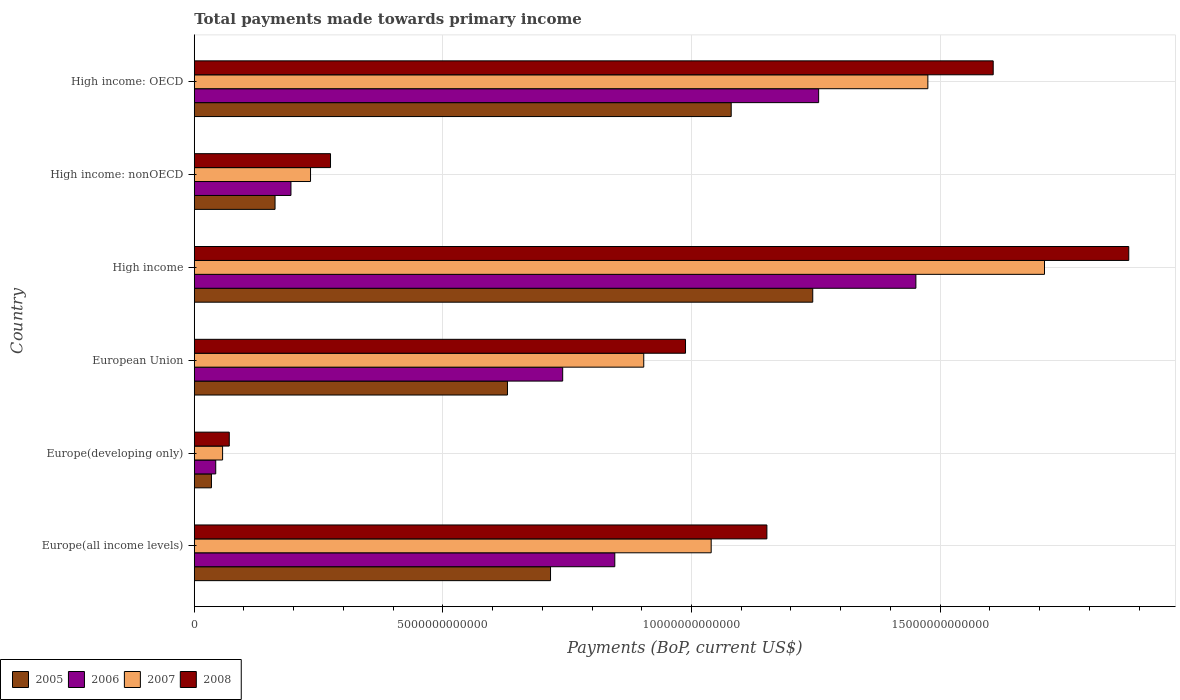How many groups of bars are there?
Make the answer very short. 6. How many bars are there on the 3rd tick from the bottom?
Your answer should be compact. 4. What is the label of the 1st group of bars from the top?
Your answer should be compact. High income: OECD. What is the total payments made towards primary income in 2008 in High income?
Your response must be concise. 1.88e+13. Across all countries, what is the maximum total payments made towards primary income in 2007?
Provide a succinct answer. 1.71e+13. Across all countries, what is the minimum total payments made towards primary income in 2005?
Offer a very short reply. 3.46e+11. In which country was the total payments made towards primary income in 2007 minimum?
Your response must be concise. Europe(developing only). What is the total total payments made towards primary income in 2007 in the graph?
Your answer should be compact. 5.42e+13. What is the difference between the total payments made towards primary income in 2006 in Europe(developing only) and that in High income?
Make the answer very short. -1.41e+13. What is the difference between the total payments made towards primary income in 2007 in Europe(developing only) and the total payments made towards primary income in 2006 in Europe(all income levels)?
Your answer should be compact. -7.89e+12. What is the average total payments made towards primary income in 2006 per country?
Your answer should be very brief. 7.55e+12. What is the difference between the total payments made towards primary income in 2007 and total payments made towards primary income in 2008 in European Union?
Offer a terse response. -8.40e+11. In how many countries, is the total payments made towards primary income in 2005 greater than 18000000000000 US$?
Keep it short and to the point. 0. What is the ratio of the total payments made towards primary income in 2006 in European Union to that in High income: OECD?
Your response must be concise. 0.59. What is the difference between the highest and the second highest total payments made towards primary income in 2005?
Give a very brief answer. 1.64e+12. What is the difference between the highest and the lowest total payments made towards primary income in 2007?
Offer a very short reply. 1.65e+13. Is the sum of the total payments made towards primary income in 2006 in High income and High income: OECD greater than the maximum total payments made towards primary income in 2008 across all countries?
Make the answer very short. Yes. Is it the case that in every country, the sum of the total payments made towards primary income in 2008 and total payments made towards primary income in 2006 is greater than the sum of total payments made towards primary income in 2007 and total payments made towards primary income in 2005?
Make the answer very short. No. What does the 3rd bar from the bottom in High income: nonOECD represents?
Provide a succinct answer. 2007. How many countries are there in the graph?
Provide a short and direct response. 6. What is the difference between two consecutive major ticks on the X-axis?
Give a very brief answer. 5.00e+12. Where does the legend appear in the graph?
Provide a succinct answer. Bottom left. How are the legend labels stacked?
Your answer should be very brief. Horizontal. What is the title of the graph?
Provide a short and direct response. Total payments made towards primary income. What is the label or title of the X-axis?
Provide a succinct answer. Payments (BoP, current US$). What is the Payments (BoP, current US$) in 2005 in Europe(all income levels)?
Your answer should be compact. 7.16e+12. What is the Payments (BoP, current US$) of 2006 in Europe(all income levels)?
Keep it short and to the point. 8.46e+12. What is the Payments (BoP, current US$) of 2007 in Europe(all income levels)?
Your answer should be compact. 1.04e+13. What is the Payments (BoP, current US$) of 2008 in Europe(all income levels)?
Your answer should be compact. 1.15e+13. What is the Payments (BoP, current US$) of 2005 in Europe(developing only)?
Provide a succinct answer. 3.46e+11. What is the Payments (BoP, current US$) of 2006 in Europe(developing only)?
Make the answer very short. 4.32e+11. What is the Payments (BoP, current US$) in 2007 in Europe(developing only)?
Provide a short and direct response. 5.70e+11. What is the Payments (BoP, current US$) of 2008 in Europe(developing only)?
Provide a short and direct response. 7.04e+11. What is the Payments (BoP, current US$) of 2005 in European Union?
Your answer should be compact. 6.30e+12. What is the Payments (BoP, current US$) in 2006 in European Union?
Your response must be concise. 7.41e+12. What is the Payments (BoP, current US$) in 2007 in European Union?
Provide a short and direct response. 9.04e+12. What is the Payments (BoP, current US$) of 2008 in European Union?
Your answer should be compact. 9.88e+12. What is the Payments (BoP, current US$) in 2005 in High income?
Your answer should be very brief. 1.24e+13. What is the Payments (BoP, current US$) of 2006 in High income?
Offer a very short reply. 1.45e+13. What is the Payments (BoP, current US$) in 2007 in High income?
Ensure brevity in your answer.  1.71e+13. What is the Payments (BoP, current US$) in 2008 in High income?
Provide a succinct answer. 1.88e+13. What is the Payments (BoP, current US$) in 2005 in High income: nonOECD?
Offer a very short reply. 1.62e+12. What is the Payments (BoP, current US$) of 2006 in High income: nonOECD?
Provide a succinct answer. 1.94e+12. What is the Payments (BoP, current US$) in 2007 in High income: nonOECD?
Provide a short and direct response. 2.34e+12. What is the Payments (BoP, current US$) of 2008 in High income: nonOECD?
Make the answer very short. 2.74e+12. What is the Payments (BoP, current US$) of 2005 in High income: OECD?
Your answer should be compact. 1.08e+13. What is the Payments (BoP, current US$) in 2006 in High income: OECD?
Offer a terse response. 1.26e+13. What is the Payments (BoP, current US$) in 2007 in High income: OECD?
Ensure brevity in your answer.  1.48e+13. What is the Payments (BoP, current US$) of 2008 in High income: OECD?
Provide a short and direct response. 1.61e+13. Across all countries, what is the maximum Payments (BoP, current US$) in 2005?
Offer a terse response. 1.24e+13. Across all countries, what is the maximum Payments (BoP, current US$) in 2006?
Make the answer very short. 1.45e+13. Across all countries, what is the maximum Payments (BoP, current US$) in 2007?
Your answer should be very brief. 1.71e+13. Across all countries, what is the maximum Payments (BoP, current US$) in 2008?
Your answer should be very brief. 1.88e+13. Across all countries, what is the minimum Payments (BoP, current US$) in 2005?
Your response must be concise. 3.46e+11. Across all countries, what is the minimum Payments (BoP, current US$) of 2006?
Offer a terse response. 4.32e+11. Across all countries, what is the minimum Payments (BoP, current US$) in 2007?
Your answer should be very brief. 5.70e+11. Across all countries, what is the minimum Payments (BoP, current US$) in 2008?
Offer a very short reply. 7.04e+11. What is the total Payments (BoP, current US$) in 2005 in the graph?
Offer a terse response. 3.87e+13. What is the total Payments (BoP, current US$) in 2006 in the graph?
Your answer should be compact. 4.53e+13. What is the total Payments (BoP, current US$) of 2007 in the graph?
Your answer should be compact. 5.42e+13. What is the total Payments (BoP, current US$) in 2008 in the graph?
Provide a succinct answer. 5.97e+13. What is the difference between the Payments (BoP, current US$) of 2005 in Europe(all income levels) and that in Europe(developing only)?
Your response must be concise. 6.82e+12. What is the difference between the Payments (BoP, current US$) of 2006 in Europe(all income levels) and that in Europe(developing only)?
Provide a succinct answer. 8.03e+12. What is the difference between the Payments (BoP, current US$) in 2007 in Europe(all income levels) and that in Europe(developing only)?
Your answer should be compact. 9.83e+12. What is the difference between the Payments (BoP, current US$) in 2008 in Europe(all income levels) and that in Europe(developing only)?
Offer a very short reply. 1.08e+13. What is the difference between the Payments (BoP, current US$) of 2005 in Europe(all income levels) and that in European Union?
Ensure brevity in your answer.  8.66e+11. What is the difference between the Payments (BoP, current US$) in 2006 in Europe(all income levels) and that in European Union?
Offer a very short reply. 1.05e+12. What is the difference between the Payments (BoP, current US$) of 2007 in Europe(all income levels) and that in European Union?
Offer a terse response. 1.36e+12. What is the difference between the Payments (BoP, current US$) in 2008 in Europe(all income levels) and that in European Union?
Provide a short and direct response. 1.64e+12. What is the difference between the Payments (BoP, current US$) in 2005 in Europe(all income levels) and that in High income?
Give a very brief answer. -5.27e+12. What is the difference between the Payments (BoP, current US$) in 2006 in Europe(all income levels) and that in High income?
Provide a succinct answer. -6.06e+12. What is the difference between the Payments (BoP, current US$) in 2007 in Europe(all income levels) and that in High income?
Your answer should be very brief. -6.70e+12. What is the difference between the Payments (BoP, current US$) in 2008 in Europe(all income levels) and that in High income?
Keep it short and to the point. -7.28e+12. What is the difference between the Payments (BoP, current US$) in 2005 in Europe(all income levels) and that in High income: nonOECD?
Your answer should be compact. 5.54e+12. What is the difference between the Payments (BoP, current US$) of 2006 in Europe(all income levels) and that in High income: nonOECD?
Offer a very short reply. 6.51e+12. What is the difference between the Payments (BoP, current US$) in 2007 in Europe(all income levels) and that in High income: nonOECD?
Provide a short and direct response. 8.06e+12. What is the difference between the Payments (BoP, current US$) of 2008 in Europe(all income levels) and that in High income: nonOECD?
Give a very brief answer. 8.78e+12. What is the difference between the Payments (BoP, current US$) of 2005 in Europe(all income levels) and that in High income: OECD?
Your answer should be compact. -3.63e+12. What is the difference between the Payments (BoP, current US$) of 2006 in Europe(all income levels) and that in High income: OECD?
Your response must be concise. -4.10e+12. What is the difference between the Payments (BoP, current US$) in 2007 in Europe(all income levels) and that in High income: OECD?
Ensure brevity in your answer.  -4.36e+12. What is the difference between the Payments (BoP, current US$) of 2008 in Europe(all income levels) and that in High income: OECD?
Ensure brevity in your answer.  -4.55e+12. What is the difference between the Payments (BoP, current US$) of 2005 in Europe(developing only) and that in European Union?
Your answer should be very brief. -5.95e+12. What is the difference between the Payments (BoP, current US$) in 2006 in Europe(developing only) and that in European Union?
Offer a terse response. -6.98e+12. What is the difference between the Payments (BoP, current US$) of 2007 in Europe(developing only) and that in European Union?
Give a very brief answer. -8.47e+12. What is the difference between the Payments (BoP, current US$) in 2008 in Europe(developing only) and that in European Union?
Keep it short and to the point. -9.18e+12. What is the difference between the Payments (BoP, current US$) in 2005 in Europe(developing only) and that in High income?
Your answer should be very brief. -1.21e+13. What is the difference between the Payments (BoP, current US$) in 2006 in Europe(developing only) and that in High income?
Your answer should be compact. -1.41e+13. What is the difference between the Payments (BoP, current US$) of 2007 in Europe(developing only) and that in High income?
Ensure brevity in your answer.  -1.65e+13. What is the difference between the Payments (BoP, current US$) in 2008 in Europe(developing only) and that in High income?
Make the answer very short. -1.81e+13. What is the difference between the Payments (BoP, current US$) of 2005 in Europe(developing only) and that in High income: nonOECD?
Offer a very short reply. -1.28e+12. What is the difference between the Payments (BoP, current US$) in 2006 in Europe(developing only) and that in High income: nonOECD?
Ensure brevity in your answer.  -1.51e+12. What is the difference between the Payments (BoP, current US$) of 2007 in Europe(developing only) and that in High income: nonOECD?
Give a very brief answer. -1.77e+12. What is the difference between the Payments (BoP, current US$) in 2008 in Europe(developing only) and that in High income: nonOECD?
Offer a terse response. -2.04e+12. What is the difference between the Payments (BoP, current US$) of 2005 in Europe(developing only) and that in High income: OECD?
Keep it short and to the point. -1.05e+13. What is the difference between the Payments (BoP, current US$) in 2006 in Europe(developing only) and that in High income: OECD?
Provide a short and direct response. -1.21e+13. What is the difference between the Payments (BoP, current US$) in 2007 in Europe(developing only) and that in High income: OECD?
Provide a succinct answer. -1.42e+13. What is the difference between the Payments (BoP, current US$) in 2008 in Europe(developing only) and that in High income: OECD?
Make the answer very short. -1.54e+13. What is the difference between the Payments (BoP, current US$) in 2005 in European Union and that in High income?
Ensure brevity in your answer.  -6.14e+12. What is the difference between the Payments (BoP, current US$) in 2006 in European Union and that in High income?
Offer a very short reply. -7.10e+12. What is the difference between the Payments (BoP, current US$) in 2007 in European Union and that in High income?
Your response must be concise. -8.06e+12. What is the difference between the Payments (BoP, current US$) in 2008 in European Union and that in High income?
Offer a terse response. -8.91e+12. What is the difference between the Payments (BoP, current US$) in 2005 in European Union and that in High income: nonOECD?
Make the answer very short. 4.67e+12. What is the difference between the Payments (BoP, current US$) of 2006 in European Union and that in High income: nonOECD?
Your answer should be compact. 5.47e+12. What is the difference between the Payments (BoP, current US$) in 2007 in European Union and that in High income: nonOECD?
Give a very brief answer. 6.70e+12. What is the difference between the Payments (BoP, current US$) of 2008 in European Union and that in High income: nonOECD?
Keep it short and to the point. 7.14e+12. What is the difference between the Payments (BoP, current US$) in 2005 in European Union and that in High income: OECD?
Make the answer very short. -4.50e+12. What is the difference between the Payments (BoP, current US$) of 2006 in European Union and that in High income: OECD?
Your answer should be very brief. -5.15e+12. What is the difference between the Payments (BoP, current US$) in 2007 in European Union and that in High income: OECD?
Give a very brief answer. -5.71e+12. What is the difference between the Payments (BoP, current US$) of 2008 in European Union and that in High income: OECD?
Offer a terse response. -6.19e+12. What is the difference between the Payments (BoP, current US$) of 2005 in High income and that in High income: nonOECD?
Provide a short and direct response. 1.08e+13. What is the difference between the Payments (BoP, current US$) in 2006 in High income and that in High income: nonOECD?
Provide a short and direct response. 1.26e+13. What is the difference between the Payments (BoP, current US$) of 2007 in High income and that in High income: nonOECD?
Give a very brief answer. 1.48e+13. What is the difference between the Payments (BoP, current US$) of 2008 in High income and that in High income: nonOECD?
Your answer should be very brief. 1.61e+13. What is the difference between the Payments (BoP, current US$) of 2005 in High income and that in High income: OECD?
Keep it short and to the point. 1.64e+12. What is the difference between the Payments (BoP, current US$) in 2006 in High income and that in High income: OECD?
Your answer should be very brief. 1.96e+12. What is the difference between the Payments (BoP, current US$) of 2007 in High income and that in High income: OECD?
Provide a succinct answer. 2.35e+12. What is the difference between the Payments (BoP, current US$) of 2008 in High income and that in High income: OECD?
Your response must be concise. 2.73e+12. What is the difference between the Payments (BoP, current US$) of 2005 in High income: nonOECD and that in High income: OECD?
Your answer should be compact. -9.17e+12. What is the difference between the Payments (BoP, current US$) in 2006 in High income: nonOECD and that in High income: OECD?
Your response must be concise. -1.06e+13. What is the difference between the Payments (BoP, current US$) in 2007 in High income: nonOECD and that in High income: OECD?
Offer a terse response. -1.24e+13. What is the difference between the Payments (BoP, current US$) of 2008 in High income: nonOECD and that in High income: OECD?
Ensure brevity in your answer.  -1.33e+13. What is the difference between the Payments (BoP, current US$) in 2005 in Europe(all income levels) and the Payments (BoP, current US$) in 2006 in Europe(developing only)?
Your answer should be compact. 6.73e+12. What is the difference between the Payments (BoP, current US$) of 2005 in Europe(all income levels) and the Payments (BoP, current US$) of 2007 in Europe(developing only)?
Provide a short and direct response. 6.60e+12. What is the difference between the Payments (BoP, current US$) of 2005 in Europe(all income levels) and the Payments (BoP, current US$) of 2008 in Europe(developing only)?
Your answer should be very brief. 6.46e+12. What is the difference between the Payments (BoP, current US$) in 2006 in Europe(all income levels) and the Payments (BoP, current US$) in 2007 in Europe(developing only)?
Provide a succinct answer. 7.89e+12. What is the difference between the Payments (BoP, current US$) in 2006 in Europe(all income levels) and the Payments (BoP, current US$) in 2008 in Europe(developing only)?
Provide a short and direct response. 7.75e+12. What is the difference between the Payments (BoP, current US$) of 2007 in Europe(all income levels) and the Payments (BoP, current US$) of 2008 in Europe(developing only)?
Your response must be concise. 9.69e+12. What is the difference between the Payments (BoP, current US$) of 2005 in Europe(all income levels) and the Payments (BoP, current US$) of 2006 in European Union?
Make the answer very short. -2.45e+11. What is the difference between the Payments (BoP, current US$) in 2005 in Europe(all income levels) and the Payments (BoP, current US$) in 2007 in European Union?
Provide a succinct answer. -1.87e+12. What is the difference between the Payments (BoP, current US$) in 2005 in Europe(all income levels) and the Payments (BoP, current US$) in 2008 in European Union?
Your answer should be compact. -2.71e+12. What is the difference between the Payments (BoP, current US$) in 2006 in Europe(all income levels) and the Payments (BoP, current US$) in 2007 in European Union?
Your answer should be compact. -5.82e+11. What is the difference between the Payments (BoP, current US$) of 2006 in Europe(all income levels) and the Payments (BoP, current US$) of 2008 in European Union?
Offer a terse response. -1.42e+12. What is the difference between the Payments (BoP, current US$) in 2007 in Europe(all income levels) and the Payments (BoP, current US$) in 2008 in European Union?
Your response must be concise. 5.16e+11. What is the difference between the Payments (BoP, current US$) of 2005 in Europe(all income levels) and the Payments (BoP, current US$) of 2006 in High income?
Give a very brief answer. -7.35e+12. What is the difference between the Payments (BoP, current US$) of 2005 in Europe(all income levels) and the Payments (BoP, current US$) of 2007 in High income?
Offer a terse response. -9.93e+12. What is the difference between the Payments (BoP, current US$) of 2005 in Europe(all income levels) and the Payments (BoP, current US$) of 2008 in High income?
Provide a short and direct response. -1.16e+13. What is the difference between the Payments (BoP, current US$) in 2006 in Europe(all income levels) and the Payments (BoP, current US$) in 2007 in High income?
Your answer should be very brief. -8.64e+12. What is the difference between the Payments (BoP, current US$) of 2006 in Europe(all income levels) and the Payments (BoP, current US$) of 2008 in High income?
Provide a short and direct response. -1.03e+13. What is the difference between the Payments (BoP, current US$) of 2007 in Europe(all income levels) and the Payments (BoP, current US$) of 2008 in High income?
Offer a terse response. -8.40e+12. What is the difference between the Payments (BoP, current US$) in 2005 in Europe(all income levels) and the Payments (BoP, current US$) in 2006 in High income: nonOECD?
Your response must be concise. 5.22e+12. What is the difference between the Payments (BoP, current US$) in 2005 in Europe(all income levels) and the Payments (BoP, current US$) in 2007 in High income: nonOECD?
Keep it short and to the point. 4.83e+12. What is the difference between the Payments (BoP, current US$) in 2005 in Europe(all income levels) and the Payments (BoP, current US$) in 2008 in High income: nonOECD?
Offer a very short reply. 4.42e+12. What is the difference between the Payments (BoP, current US$) in 2006 in Europe(all income levels) and the Payments (BoP, current US$) in 2007 in High income: nonOECD?
Your answer should be compact. 6.12e+12. What is the difference between the Payments (BoP, current US$) of 2006 in Europe(all income levels) and the Payments (BoP, current US$) of 2008 in High income: nonOECD?
Ensure brevity in your answer.  5.72e+12. What is the difference between the Payments (BoP, current US$) of 2007 in Europe(all income levels) and the Payments (BoP, current US$) of 2008 in High income: nonOECD?
Offer a very short reply. 7.66e+12. What is the difference between the Payments (BoP, current US$) in 2005 in Europe(all income levels) and the Payments (BoP, current US$) in 2006 in High income: OECD?
Give a very brief answer. -5.39e+12. What is the difference between the Payments (BoP, current US$) of 2005 in Europe(all income levels) and the Payments (BoP, current US$) of 2007 in High income: OECD?
Make the answer very short. -7.59e+12. What is the difference between the Payments (BoP, current US$) in 2005 in Europe(all income levels) and the Payments (BoP, current US$) in 2008 in High income: OECD?
Provide a short and direct response. -8.90e+12. What is the difference between the Payments (BoP, current US$) of 2006 in Europe(all income levels) and the Payments (BoP, current US$) of 2007 in High income: OECD?
Provide a short and direct response. -6.30e+12. What is the difference between the Payments (BoP, current US$) of 2006 in Europe(all income levels) and the Payments (BoP, current US$) of 2008 in High income: OECD?
Ensure brevity in your answer.  -7.61e+12. What is the difference between the Payments (BoP, current US$) of 2007 in Europe(all income levels) and the Payments (BoP, current US$) of 2008 in High income: OECD?
Your answer should be very brief. -5.67e+12. What is the difference between the Payments (BoP, current US$) in 2005 in Europe(developing only) and the Payments (BoP, current US$) in 2006 in European Union?
Offer a terse response. -7.06e+12. What is the difference between the Payments (BoP, current US$) of 2005 in Europe(developing only) and the Payments (BoP, current US$) of 2007 in European Union?
Give a very brief answer. -8.69e+12. What is the difference between the Payments (BoP, current US$) of 2005 in Europe(developing only) and the Payments (BoP, current US$) of 2008 in European Union?
Offer a very short reply. -9.53e+12. What is the difference between the Payments (BoP, current US$) in 2006 in Europe(developing only) and the Payments (BoP, current US$) in 2007 in European Union?
Ensure brevity in your answer.  -8.61e+12. What is the difference between the Payments (BoP, current US$) of 2006 in Europe(developing only) and the Payments (BoP, current US$) of 2008 in European Union?
Make the answer very short. -9.45e+12. What is the difference between the Payments (BoP, current US$) in 2007 in Europe(developing only) and the Payments (BoP, current US$) in 2008 in European Union?
Give a very brief answer. -9.31e+12. What is the difference between the Payments (BoP, current US$) in 2005 in Europe(developing only) and the Payments (BoP, current US$) in 2006 in High income?
Provide a succinct answer. -1.42e+13. What is the difference between the Payments (BoP, current US$) in 2005 in Europe(developing only) and the Payments (BoP, current US$) in 2007 in High income?
Provide a short and direct response. -1.68e+13. What is the difference between the Payments (BoP, current US$) of 2005 in Europe(developing only) and the Payments (BoP, current US$) of 2008 in High income?
Your answer should be compact. -1.84e+13. What is the difference between the Payments (BoP, current US$) of 2006 in Europe(developing only) and the Payments (BoP, current US$) of 2007 in High income?
Give a very brief answer. -1.67e+13. What is the difference between the Payments (BoP, current US$) of 2006 in Europe(developing only) and the Payments (BoP, current US$) of 2008 in High income?
Provide a succinct answer. -1.84e+13. What is the difference between the Payments (BoP, current US$) in 2007 in Europe(developing only) and the Payments (BoP, current US$) in 2008 in High income?
Offer a terse response. -1.82e+13. What is the difference between the Payments (BoP, current US$) of 2005 in Europe(developing only) and the Payments (BoP, current US$) of 2006 in High income: nonOECD?
Offer a terse response. -1.60e+12. What is the difference between the Payments (BoP, current US$) of 2005 in Europe(developing only) and the Payments (BoP, current US$) of 2007 in High income: nonOECD?
Give a very brief answer. -1.99e+12. What is the difference between the Payments (BoP, current US$) of 2005 in Europe(developing only) and the Payments (BoP, current US$) of 2008 in High income: nonOECD?
Offer a terse response. -2.39e+12. What is the difference between the Payments (BoP, current US$) in 2006 in Europe(developing only) and the Payments (BoP, current US$) in 2007 in High income: nonOECD?
Offer a very short reply. -1.91e+12. What is the difference between the Payments (BoP, current US$) in 2006 in Europe(developing only) and the Payments (BoP, current US$) in 2008 in High income: nonOECD?
Ensure brevity in your answer.  -2.31e+12. What is the difference between the Payments (BoP, current US$) of 2007 in Europe(developing only) and the Payments (BoP, current US$) of 2008 in High income: nonOECD?
Keep it short and to the point. -2.17e+12. What is the difference between the Payments (BoP, current US$) of 2005 in Europe(developing only) and the Payments (BoP, current US$) of 2006 in High income: OECD?
Provide a short and direct response. -1.22e+13. What is the difference between the Payments (BoP, current US$) of 2005 in Europe(developing only) and the Payments (BoP, current US$) of 2007 in High income: OECD?
Your answer should be compact. -1.44e+13. What is the difference between the Payments (BoP, current US$) in 2005 in Europe(developing only) and the Payments (BoP, current US$) in 2008 in High income: OECD?
Provide a succinct answer. -1.57e+13. What is the difference between the Payments (BoP, current US$) in 2006 in Europe(developing only) and the Payments (BoP, current US$) in 2007 in High income: OECD?
Ensure brevity in your answer.  -1.43e+13. What is the difference between the Payments (BoP, current US$) of 2006 in Europe(developing only) and the Payments (BoP, current US$) of 2008 in High income: OECD?
Give a very brief answer. -1.56e+13. What is the difference between the Payments (BoP, current US$) in 2007 in Europe(developing only) and the Payments (BoP, current US$) in 2008 in High income: OECD?
Offer a terse response. -1.55e+13. What is the difference between the Payments (BoP, current US$) in 2005 in European Union and the Payments (BoP, current US$) in 2006 in High income?
Give a very brief answer. -8.21e+12. What is the difference between the Payments (BoP, current US$) in 2005 in European Union and the Payments (BoP, current US$) in 2007 in High income?
Your answer should be compact. -1.08e+13. What is the difference between the Payments (BoP, current US$) in 2005 in European Union and the Payments (BoP, current US$) in 2008 in High income?
Offer a very short reply. -1.25e+13. What is the difference between the Payments (BoP, current US$) in 2006 in European Union and the Payments (BoP, current US$) in 2007 in High income?
Keep it short and to the point. -9.69e+12. What is the difference between the Payments (BoP, current US$) in 2006 in European Union and the Payments (BoP, current US$) in 2008 in High income?
Your response must be concise. -1.14e+13. What is the difference between the Payments (BoP, current US$) of 2007 in European Union and the Payments (BoP, current US$) of 2008 in High income?
Provide a succinct answer. -9.75e+12. What is the difference between the Payments (BoP, current US$) in 2005 in European Union and the Payments (BoP, current US$) in 2006 in High income: nonOECD?
Give a very brief answer. 4.35e+12. What is the difference between the Payments (BoP, current US$) of 2005 in European Union and the Payments (BoP, current US$) of 2007 in High income: nonOECD?
Offer a terse response. 3.96e+12. What is the difference between the Payments (BoP, current US$) in 2005 in European Union and the Payments (BoP, current US$) in 2008 in High income: nonOECD?
Keep it short and to the point. 3.56e+12. What is the difference between the Payments (BoP, current US$) of 2006 in European Union and the Payments (BoP, current US$) of 2007 in High income: nonOECD?
Your response must be concise. 5.07e+12. What is the difference between the Payments (BoP, current US$) in 2006 in European Union and the Payments (BoP, current US$) in 2008 in High income: nonOECD?
Offer a terse response. 4.67e+12. What is the difference between the Payments (BoP, current US$) of 2007 in European Union and the Payments (BoP, current US$) of 2008 in High income: nonOECD?
Your answer should be very brief. 6.30e+12. What is the difference between the Payments (BoP, current US$) in 2005 in European Union and the Payments (BoP, current US$) in 2006 in High income: OECD?
Keep it short and to the point. -6.26e+12. What is the difference between the Payments (BoP, current US$) in 2005 in European Union and the Payments (BoP, current US$) in 2007 in High income: OECD?
Ensure brevity in your answer.  -8.45e+12. What is the difference between the Payments (BoP, current US$) of 2005 in European Union and the Payments (BoP, current US$) of 2008 in High income: OECD?
Your answer should be very brief. -9.77e+12. What is the difference between the Payments (BoP, current US$) in 2006 in European Union and the Payments (BoP, current US$) in 2007 in High income: OECD?
Your response must be concise. -7.34e+12. What is the difference between the Payments (BoP, current US$) of 2006 in European Union and the Payments (BoP, current US$) of 2008 in High income: OECD?
Provide a short and direct response. -8.66e+12. What is the difference between the Payments (BoP, current US$) of 2007 in European Union and the Payments (BoP, current US$) of 2008 in High income: OECD?
Provide a short and direct response. -7.03e+12. What is the difference between the Payments (BoP, current US$) in 2005 in High income and the Payments (BoP, current US$) in 2006 in High income: nonOECD?
Keep it short and to the point. 1.05e+13. What is the difference between the Payments (BoP, current US$) of 2005 in High income and the Payments (BoP, current US$) of 2007 in High income: nonOECD?
Make the answer very short. 1.01e+13. What is the difference between the Payments (BoP, current US$) of 2005 in High income and the Payments (BoP, current US$) of 2008 in High income: nonOECD?
Make the answer very short. 9.70e+12. What is the difference between the Payments (BoP, current US$) in 2006 in High income and the Payments (BoP, current US$) in 2007 in High income: nonOECD?
Your response must be concise. 1.22e+13. What is the difference between the Payments (BoP, current US$) of 2006 in High income and the Payments (BoP, current US$) of 2008 in High income: nonOECD?
Give a very brief answer. 1.18e+13. What is the difference between the Payments (BoP, current US$) of 2007 in High income and the Payments (BoP, current US$) of 2008 in High income: nonOECD?
Give a very brief answer. 1.44e+13. What is the difference between the Payments (BoP, current US$) of 2005 in High income and the Payments (BoP, current US$) of 2006 in High income: OECD?
Your answer should be very brief. -1.18e+11. What is the difference between the Payments (BoP, current US$) of 2005 in High income and the Payments (BoP, current US$) of 2007 in High income: OECD?
Ensure brevity in your answer.  -2.32e+12. What is the difference between the Payments (BoP, current US$) of 2005 in High income and the Payments (BoP, current US$) of 2008 in High income: OECD?
Provide a short and direct response. -3.63e+12. What is the difference between the Payments (BoP, current US$) of 2006 in High income and the Payments (BoP, current US$) of 2007 in High income: OECD?
Your answer should be very brief. -2.41e+11. What is the difference between the Payments (BoP, current US$) of 2006 in High income and the Payments (BoP, current US$) of 2008 in High income: OECD?
Your answer should be compact. -1.55e+12. What is the difference between the Payments (BoP, current US$) in 2007 in High income and the Payments (BoP, current US$) in 2008 in High income: OECD?
Provide a succinct answer. 1.03e+12. What is the difference between the Payments (BoP, current US$) of 2005 in High income: nonOECD and the Payments (BoP, current US$) of 2006 in High income: OECD?
Your answer should be very brief. -1.09e+13. What is the difference between the Payments (BoP, current US$) in 2005 in High income: nonOECD and the Payments (BoP, current US$) in 2007 in High income: OECD?
Give a very brief answer. -1.31e+13. What is the difference between the Payments (BoP, current US$) of 2005 in High income: nonOECD and the Payments (BoP, current US$) of 2008 in High income: OECD?
Give a very brief answer. -1.44e+13. What is the difference between the Payments (BoP, current US$) in 2006 in High income: nonOECD and the Payments (BoP, current US$) in 2007 in High income: OECD?
Provide a short and direct response. -1.28e+13. What is the difference between the Payments (BoP, current US$) of 2006 in High income: nonOECD and the Payments (BoP, current US$) of 2008 in High income: OECD?
Offer a terse response. -1.41e+13. What is the difference between the Payments (BoP, current US$) of 2007 in High income: nonOECD and the Payments (BoP, current US$) of 2008 in High income: OECD?
Provide a succinct answer. -1.37e+13. What is the average Payments (BoP, current US$) in 2005 per country?
Give a very brief answer. 6.45e+12. What is the average Payments (BoP, current US$) in 2006 per country?
Your answer should be very brief. 7.55e+12. What is the average Payments (BoP, current US$) of 2007 per country?
Make the answer very short. 9.03e+12. What is the average Payments (BoP, current US$) in 2008 per country?
Keep it short and to the point. 9.95e+12. What is the difference between the Payments (BoP, current US$) of 2005 and Payments (BoP, current US$) of 2006 in Europe(all income levels)?
Give a very brief answer. -1.29e+12. What is the difference between the Payments (BoP, current US$) of 2005 and Payments (BoP, current US$) of 2007 in Europe(all income levels)?
Ensure brevity in your answer.  -3.23e+12. What is the difference between the Payments (BoP, current US$) in 2005 and Payments (BoP, current US$) in 2008 in Europe(all income levels)?
Provide a short and direct response. -4.35e+12. What is the difference between the Payments (BoP, current US$) in 2006 and Payments (BoP, current US$) in 2007 in Europe(all income levels)?
Keep it short and to the point. -1.94e+12. What is the difference between the Payments (BoP, current US$) of 2006 and Payments (BoP, current US$) of 2008 in Europe(all income levels)?
Your answer should be compact. -3.06e+12. What is the difference between the Payments (BoP, current US$) in 2007 and Payments (BoP, current US$) in 2008 in Europe(all income levels)?
Make the answer very short. -1.12e+12. What is the difference between the Payments (BoP, current US$) of 2005 and Payments (BoP, current US$) of 2006 in Europe(developing only)?
Make the answer very short. -8.59e+1. What is the difference between the Payments (BoP, current US$) in 2005 and Payments (BoP, current US$) in 2007 in Europe(developing only)?
Provide a short and direct response. -2.24e+11. What is the difference between the Payments (BoP, current US$) of 2005 and Payments (BoP, current US$) of 2008 in Europe(developing only)?
Offer a terse response. -3.58e+11. What is the difference between the Payments (BoP, current US$) of 2006 and Payments (BoP, current US$) of 2007 in Europe(developing only)?
Provide a short and direct response. -1.38e+11. What is the difference between the Payments (BoP, current US$) of 2006 and Payments (BoP, current US$) of 2008 in Europe(developing only)?
Provide a short and direct response. -2.72e+11. What is the difference between the Payments (BoP, current US$) in 2007 and Payments (BoP, current US$) in 2008 in Europe(developing only)?
Your answer should be compact. -1.34e+11. What is the difference between the Payments (BoP, current US$) in 2005 and Payments (BoP, current US$) in 2006 in European Union?
Keep it short and to the point. -1.11e+12. What is the difference between the Payments (BoP, current US$) in 2005 and Payments (BoP, current US$) in 2007 in European Union?
Give a very brief answer. -2.74e+12. What is the difference between the Payments (BoP, current US$) in 2005 and Payments (BoP, current US$) in 2008 in European Union?
Give a very brief answer. -3.58e+12. What is the difference between the Payments (BoP, current US$) of 2006 and Payments (BoP, current US$) of 2007 in European Union?
Provide a short and direct response. -1.63e+12. What is the difference between the Payments (BoP, current US$) in 2006 and Payments (BoP, current US$) in 2008 in European Union?
Provide a succinct answer. -2.47e+12. What is the difference between the Payments (BoP, current US$) of 2007 and Payments (BoP, current US$) of 2008 in European Union?
Your answer should be compact. -8.40e+11. What is the difference between the Payments (BoP, current US$) in 2005 and Payments (BoP, current US$) in 2006 in High income?
Offer a very short reply. -2.07e+12. What is the difference between the Payments (BoP, current US$) of 2005 and Payments (BoP, current US$) of 2007 in High income?
Provide a succinct answer. -4.66e+12. What is the difference between the Payments (BoP, current US$) in 2005 and Payments (BoP, current US$) in 2008 in High income?
Your response must be concise. -6.36e+12. What is the difference between the Payments (BoP, current US$) of 2006 and Payments (BoP, current US$) of 2007 in High income?
Your answer should be very brief. -2.59e+12. What is the difference between the Payments (BoP, current US$) in 2006 and Payments (BoP, current US$) in 2008 in High income?
Provide a short and direct response. -4.28e+12. What is the difference between the Payments (BoP, current US$) in 2007 and Payments (BoP, current US$) in 2008 in High income?
Offer a terse response. -1.69e+12. What is the difference between the Payments (BoP, current US$) in 2005 and Payments (BoP, current US$) in 2006 in High income: nonOECD?
Make the answer very short. -3.20e+11. What is the difference between the Payments (BoP, current US$) in 2005 and Payments (BoP, current US$) in 2007 in High income: nonOECD?
Make the answer very short. -7.13e+11. What is the difference between the Payments (BoP, current US$) in 2005 and Payments (BoP, current US$) in 2008 in High income: nonOECD?
Ensure brevity in your answer.  -1.12e+12. What is the difference between the Payments (BoP, current US$) in 2006 and Payments (BoP, current US$) in 2007 in High income: nonOECD?
Your answer should be compact. -3.94e+11. What is the difference between the Payments (BoP, current US$) of 2006 and Payments (BoP, current US$) of 2008 in High income: nonOECD?
Ensure brevity in your answer.  -7.96e+11. What is the difference between the Payments (BoP, current US$) in 2007 and Payments (BoP, current US$) in 2008 in High income: nonOECD?
Your answer should be compact. -4.02e+11. What is the difference between the Payments (BoP, current US$) of 2005 and Payments (BoP, current US$) of 2006 in High income: OECD?
Ensure brevity in your answer.  -1.76e+12. What is the difference between the Payments (BoP, current US$) of 2005 and Payments (BoP, current US$) of 2007 in High income: OECD?
Your response must be concise. -3.96e+12. What is the difference between the Payments (BoP, current US$) of 2005 and Payments (BoP, current US$) of 2008 in High income: OECD?
Give a very brief answer. -5.27e+12. What is the difference between the Payments (BoP, current US$) in 2006 and Payments (BoP, current US$) in 2007 in High income: OECD?
Make the answer very short. -2.20e+12. What is the difference between the Payments (BoP, current US$) of 2006 and Payments (BoP, current US$) of 2008 in High income: OECD?
Your answer should be compact. -3.51e+12. What is the difference between the Payments (BoP, current US$) of 2007 and Payments (BoP, current US$) of 2008 in High income: OECD?
Provide a short and direct response. -1.31e+12. What is the ratio of the Payments (BoP, current US$) of 2005 in Europe(all income levels) to that in Europe(developing only)?
Ensure brevity in your answer.  20.73. What is the ratio of the Payments (BoP, current US$) of 2006 in Europe(all income levels) to that in Europe(developing only)?
Your answer should be very brief. 19.59. What is the ratio of the Payments (BoP, current US$) of 2007 in Europe(all income levels) to that in Europe(developing only)?
Keep it short and to the point. 18.25. What is the ratio of the Payments (BoP, current US$) in 2008 in Europe(all income levels) to that in Europe(developing only)?
Your response must be concise. 16.36. What is the ratio of the Payments (BoP, current US$) of 2005 in Europe(all income levels) to that in European Union?
Your answer should be compact. 1.14. What is the ratio of the Payments (BoP, current US$) of 2006 in Europe(all income levels) to that in European Union?
Make the answer very short. 1.14. What is the ratio of the Payments (BoP, current US$) in 2007 in Europe(all income levels) to that in European Union?
Your answer should be very brief. 1.15. What is the ratio of the Payments (BoP, current US$) in 2008 in Europe(all income levels) to that in European Union?
Provide a short and direct response. 1.17. What is the ratio of the Payments (BoP, current US$) of 2005 in Europe(all income levels) to that in High income?
Your response must be concise. 0.58. What is the ratio of the Payments (BoP, current US$) of 2006 in Europe(all income levels) to that in High income?
Keep it short and to the point. 0.58. What is the ratio of the Payments (BoP, current US$) of 2007 in Europe(all income levels) to that in High income?
Provide a succinct answer. 0.61. What is the ratio of the Payments (BoP, current US$) in 2008 in Europe(all income levels) to that in High income?
Offer a very short reply. 0.61. What is the ratio of the Payments (BoP, current US$) in 2005 in Europe(all income levels) to that in High income: nonOECD?
Your answer should be very brief. 4.41. What is the ratio of the Payments (BoP, current US$) in 2006 in Europe(all income levels) to that in High income: nonOECD?
Your response must be concise. 4.35. What is the ratio of the Payments (BoP, current US$) in 2007 in Europe(all income levels) to that in High income: nonOECD?
Keep it short and to the point. 4.45. What is the ratio of the Payments (BoP, current US$) of 2008 in Europe(all income levels) to that in High income: nonOECD?
Ensure brevity in your answer.  4.2. What is the ratio of the Payments (BoP, current US$) of 2005 in Europe(all income levels) to that in High income: OECD?
Provide a short and direct response. 0.66. What is the ratio of the Payments (BoP, current US$) of 2006 in Europe(all income levels) to that in High income: OECD?
Provide a succinct answer. 0.67. What is the ratio of the Payments (BoP, current US$) of 2007 in Europe(all income levels) to that in High income: OECD?
Your answer should be compact. 0.7. What is the ratio of the Payments (BoP, current US$) in 2008 in Europe(all income levels) to that in High income: OECD?
Your answer should be very brief. 0.72. What is the ratio of the Payments (BoP, current US$) of 2005 in Europe(developing only) to that in European Union?
Keep it short and to the point. 0.05. What is the ratio of the Payments (BoP, current US$) of 2006 in Europe(developing only) to that in European Union?
Give a very brief answer. 0.06. What is the ratio of the Payments (BoP, current US$) of 2007 in Europe(developing only) to that in European Union?
Provide a succinct answer. 0.06. What is the ratio of the Payments (BoP, current US$) in 2008 in Europe(developing only) to that in European Union?
Offer a terse response. 0.07. What is the ratio of the Payments (BoP, current US$) in 2005 in Europe(developing only) to that in High income?
Make the answer very short. 0.03. What is the ratio of the Payments (BoP, current US$) of 2006 in Europe(developing only) to that in High income?
Keep it short and to the point. 0.03. What is the ratio of the Payments (BoP, current US$) in 2007 in Europe(developing only) to that in High income?
Your answer should be compact. 0.03. What is the ratio of the Payments (BoP, current US$) in 2008 in Europe(developing only) to that in High income?
Your answer should be very brief. 0.04. What is the ratio of the Payments (BoP, current US$) in 2005 in Europe(developing only) to that in High income: nonOECD?
Offer a very short reply. 0.21. What is the ratio of the Payments (BoP, current US$) in 2006 in Europe(developing only) to that in High income: nonOECD?
Ensure brevity in your answer.  0.22. What is the ratio of the Payments (BoP, current US$) of 2007 in Europe(developing only) to that in High income: nonOECD?
Offer a very short reply. 0.24. What is the ratio of the Payments (BoP, current US$) in 2008 in Europe(developing only) to that in High income: nonOECD?
Offer a very short reply. 0.26. What is the ratio of the Payments (BoP, current US$) of 2005 in Europe(developing only) to that in High income: OECD?
Keep it short and to the point. 0.03. What is the ratio of the Payments (BoP, current US$) of 2006 in Europe(developing only) to that in High income: OECD?
Make the answer very short. 0.03. What is the ratio of the Payments (BoP, current US$) in 2007 in Europe(developing only) to that in High income: OECD?
Offer a terse response. 0.04. What is the ratio of the Payments (BoP, current US$) in 2008 in Europe(developing only) to that in High income: OECD?
Provide a short and direct response. 0.04. What is the ratio of the Payments (BoP, current US$) of 2005 in European Union to that in High income?
Your response must be concise. 0.51. What is the ratio of the Payments (BoP, current US$) of 2006 in European Union to that in High income?
Your answer should be very brief. 0.51. What is the ratio of the Payments (BoP, current US$) of 2007 in European Union to that in High income?
Your answer should be compact. 0.53. What is the ratio of the Payments (BoP, current US$) in 2008 in European Union to that in High income?
Your answer should be very brief. 0.53. What is the ratio of the Payments (BoP, current US$) of 2005 in European Union to that in High income: nonOECD?
Your answer should be compact. 3.88. What is the ratio of the Payments (BoP, current US$) in 2006 in European Union to that in High income: nonOECD?
Provide a short and direct response. 3.81. What is the ratio of the Payments (BoP, current US$) of 2007 in European Union to that in High income: nonOECD?
Keep it short and to the point. 3.87. What is the ratio of the Payments (BoP, current US$) of 2008 in European Union to that in High income: nonOECD?
Your answer should be very brief. 3.61. What is the ratio of the Payments (BoP, current US$) of 2005 in European Union to that in High income: OECD?
Your response must be concise. 0.58. What is the ratio of the Payments (BoP, current US$) of 2006 in European Union to that in High income: OECD?
Make the answer very short. 0.59. What is the ratio of the Payments (BoP, current US$) in 2007 in European Union to that in High income: OECD?
Offer a terse response. 0.61. What is the ratio of the Payments (BoP, current US$) of 2008 in European Union to that in High income: OECD?
Ensure brevity in your answer.  0.61. What is the ratio of the Payments (BoP, current US$) of 2005 in High income to that in High income: nonOECD?
Offer a terse response. 7.66. What is the ratio of the Payments (BoP, current US$) of 2006 in High income to that in High income: nonOECD?
Offer a very short reply. 7.46. What is the ratio of the Payments (BoP, current US$) of 2007 in High income to that in High income: nonOECD?
Give a very brief answer. 7.31. What is the ratio of the Payments (BoP, current US$) in 2008 in High income to that in High income: nonOECD?
Make the answer very short. 6.86. What is the ratio of the Payments (BoP, current US$) of 2005 in High income to that in High income: OECD?
Your answer should be compact. 1.15. What is the ratio of the Payments (BoP, current US$) in 2006 in High income to that in High income: OECD?
Offer a terse response. 1.16. What is the ratio of the Payments (BoP, current US$) of 2007 in High income to that in High income: OECD?
Make the answer very short. 1.16. What is the ratio of the Payments (BoP, current US$) in 2008 in High income to that in High income: OECD?
Give a very brief answer. 1.17. What is the ratio of the Payments (BoP, current US$) in 2005 in High income: nonOECD to that in High income: OECD?
Provide a short and direct response. 0.15. What is the ratio of the Payments (BoP, current US$) in 2006 in High income: nonOECD to that in High income: OECD?
Give a very brief answer. 0.15. What is the ratio of the Payments (BoP, current US$) in 2007 in High income: nonOECD to that in High income: OECD?
Offer a very short reply. 0.16. What is the ratio of the Payments (BoP, current US$) in 2008 in High income: nonOECD to that in High income: OECD?
Give a very brief answer. 0.17. What is the difference between the highest and the second highest Payments (BoP, current US$) in 2005?
Your answer should be compact. 1.64e+12. What is the difference between the highest and the second highest Payments (BoP, current US$) of 2006?
Give a very brief answer. 1.96e+12. What is the difference between the highest and the second highest Payments (BoP, current US$) of 2007?
Provide a short and direct response. 2.35e+12. What is the difference between the highest and the second highest Payments (BoP, current US$) of 2008?
Your response must be concise. 2.73e+12. What is the difference between the highest and the lowest Payments (BoP, current US$) of 2005?
Provide a short and direct response. 1.21e+13. What is the difference between the highest and the lowest Payments (BoP, current US$) of 2006?
Give a very brief answer. 1.41e+13. What is the difference between the highest and the lowest Payments (BoP, current US$) in 2007?
Your response must be concise. 1.65e+13. What is the difference between the highest and the lowest Payments (BoP, current US$) in 2008?
Your answer should be very brief. 1.81e+13. 